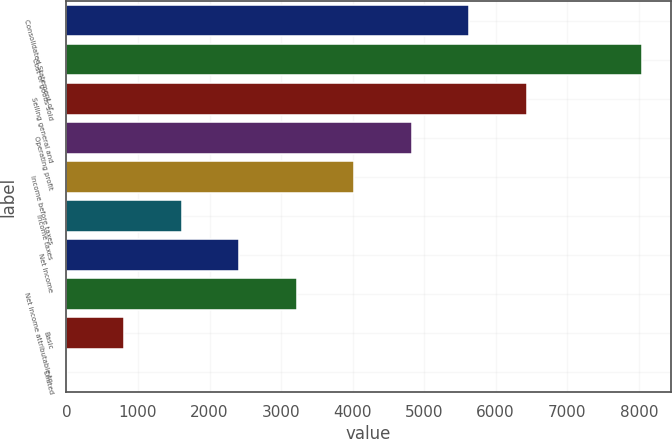<chart> <loc_0><loc_0><loc_500><loc_500><bar_chart><fcel>Consolidated Statement of<fcel>Cost of goods sold<fcel>Selling general and<fcel>Operating profit<fcel>Income before taxes<fcel>Income taxes<fcel>Net Income<fcel>Net income attributable to<fcel>Basic<fcel>Diluted<nl><fcel>5632.9<fcel>8046<fcel>6437.26<fcel>4828.54<fcel>4024.18<fcel>1611.1<fcel>2415.46<fcel>3219.82<fcel>806.74<fcel>2.38<nl></chart> 